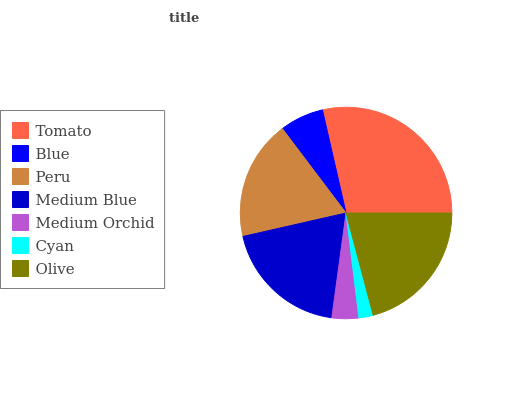Is Cyan the minimum?
Answer yes or no. Yes. Is Tomato the maximum?
Answer yes or no. Yes. Is Blue the minimum?
Answer yes or no. No. Is Blue the maximum?
Answer yes or no. No. Is Tomato greater than Blue?
Answer yes or no. Yes. Is Blue less than Tomato?
Answer yes or no. Yes. Is Blue greater than Tomato?
Answer yes or no. No. Is Tomato less than Blue?
Answer yes or no. No. Is Peru the high median?
Answer yes or no. Yes. Is Peru the low median?
Answer yes or no. Yes. Is Olive the high median?
Answer yes or no. No. Is Cyan the low median?
Answer yes or no. No. 